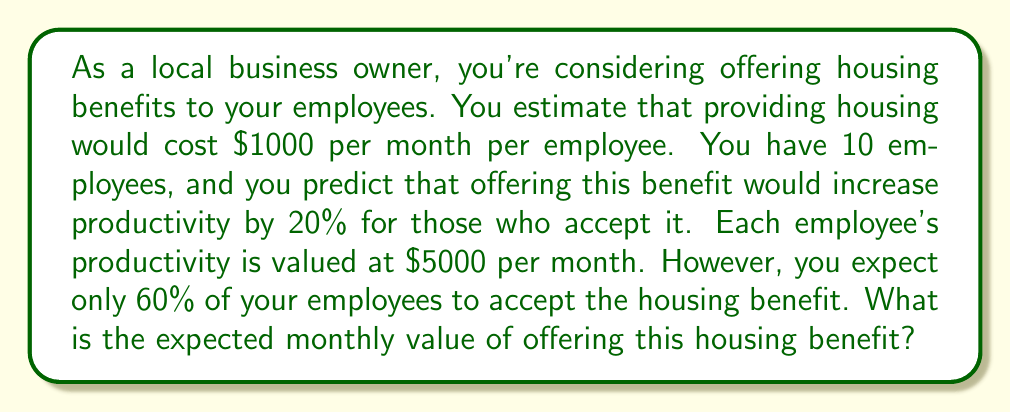Provide a solution to this math problem. Let's approach this step-by-step:

1) First, let's calculate the cost of providing housing:
   - Cost per employee = $1000 per month
   - Number of employees expected to accept = 10 * 60% = 6
   - Total housing cost = $1000 * 6 = $6000 per month

2) Now, let's calculate the value of increased productivity:
   - Current productivity value per employee = $5000 per month
   - Increase in productivity = 20% = 0.2
   - Value of increased productivity per employee = $5000 * 0.2 = $1000
   - Number of employees with increased productivity = 6
   - Total value of increased productivity = $1000 * 6 = $6000 per month

3) The expected value is the difference between the benefit and the cost:
   
   $$ E[\text{Value}] = \text{Value of Increased Productivity} - \text{Cost of Housing} $$
   
   $$ E[\text{Value}] = $6000 - $6000 = $0 $$

Therefore, the expected monthly value of offering this housing benefit is $0.
Answer: $0 